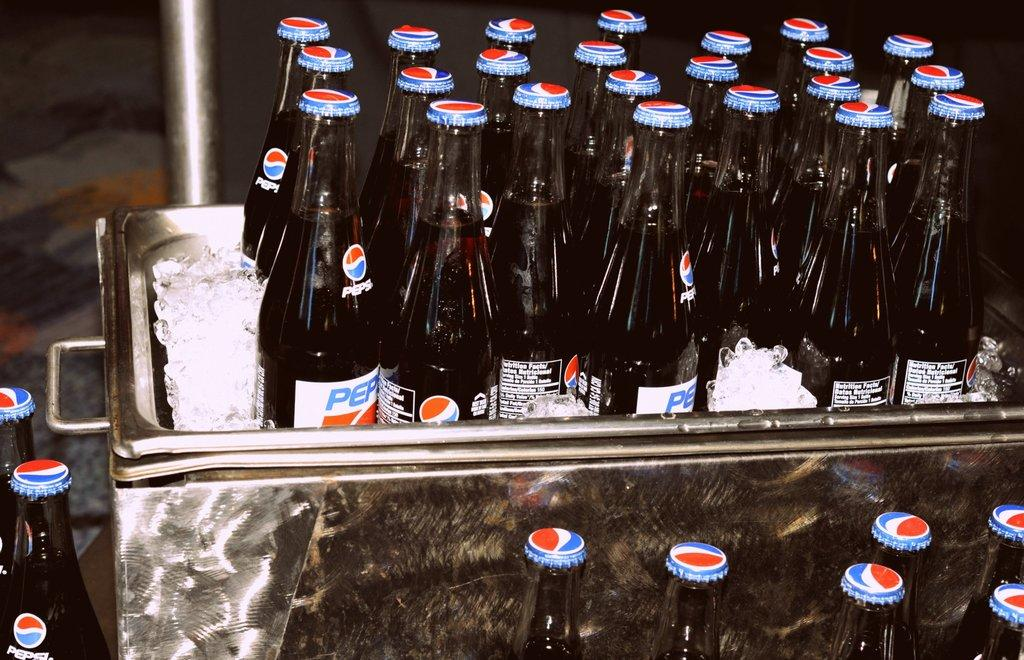<image>
Relay a brief, clear account of the picture shown. Bottles of Pepsi are lined up in rows. 